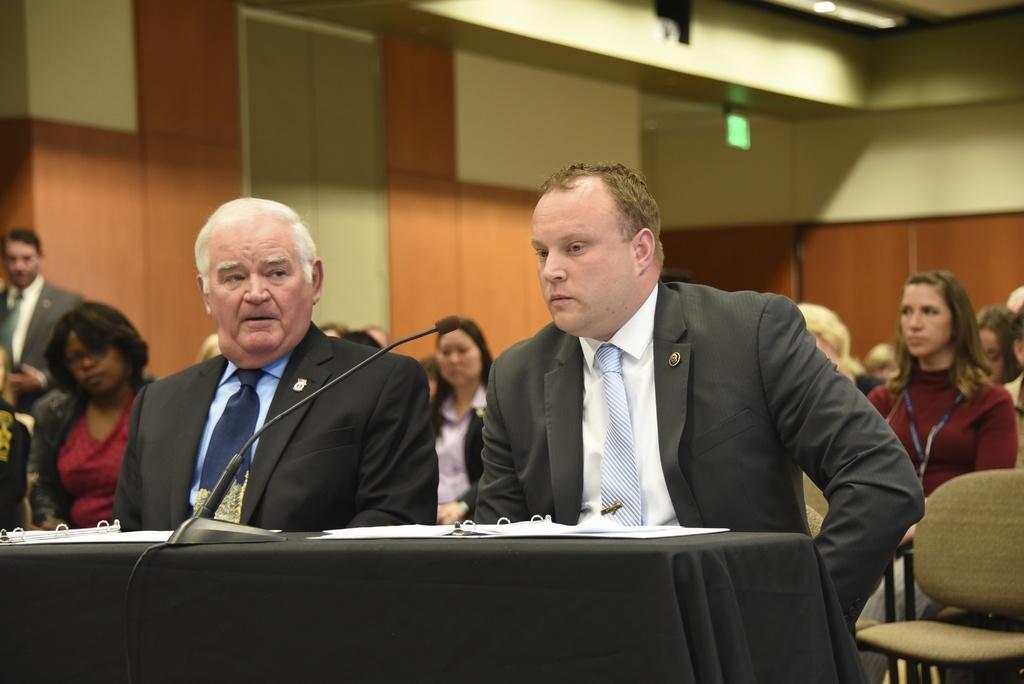How would you summarize this image in a sentence or two? The photo is taken in a meeting hall. few people are sitting on chairs. In the front two people wearing black suit are sitting. In front of them on the desk there is mic,papers. 